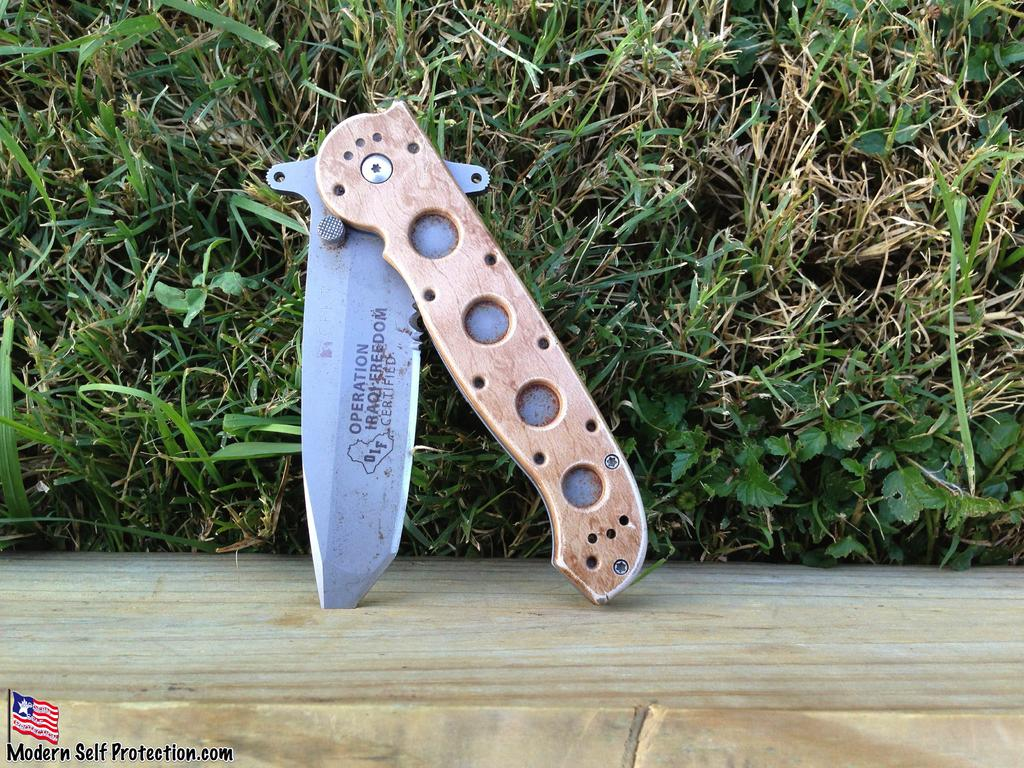What is attached to the wooden wall in the image? There is a knife on the wooden wall in the image. What type of vegetation can be seen in the image? There are grass plants present in the image. What letter can be seen on the handle of the knife in the image? There is no letter visible on the handle of the knife in the image. What tool is used to hit nails in the image? There is no hammer present in the image. 